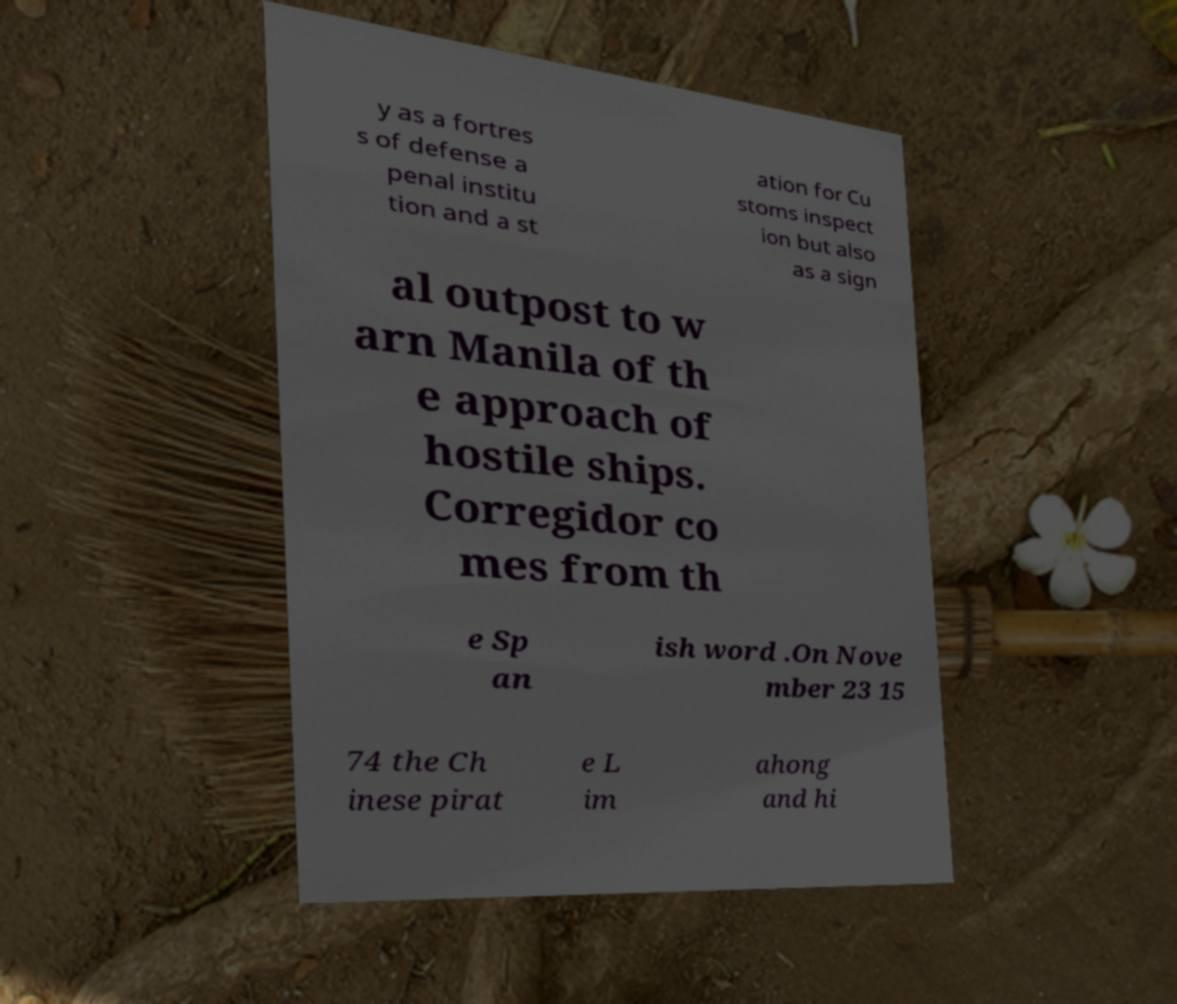Could you assist in decoding the text presented in this image and type it out clearly? y as a fortres s of defense a penal institu tion and a st ation for Cu stoms inspect ion but also as a sign al outpost to w arn Manila of th e approach of hostile ships. Corregidor co mes from th e Sp an ish word .On Nove mber 23 15 74 the Ch inese pirat e L im ahong and hi 